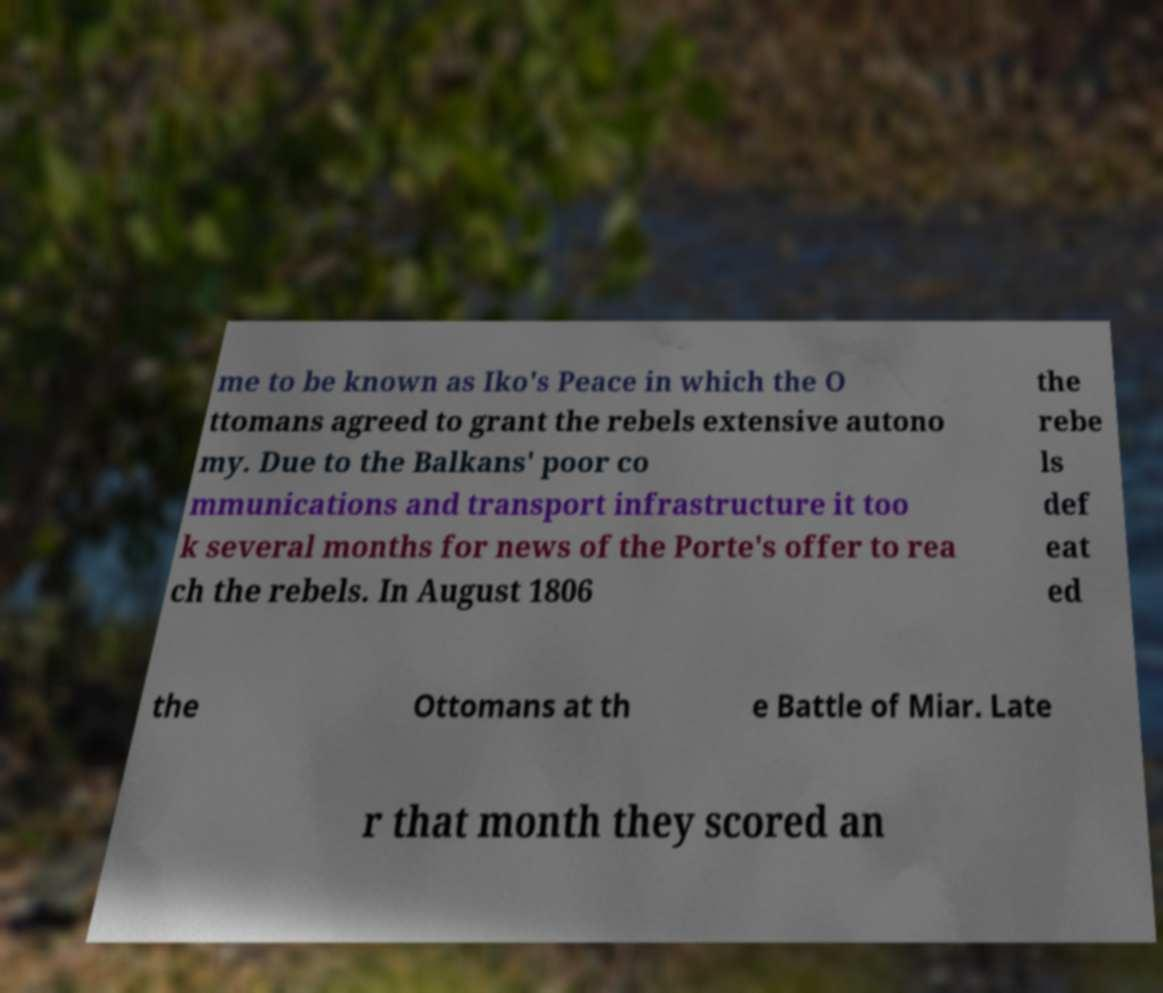Could you extract and type out the text from this image? me to be known as Iko's Peace in which the O ttomans agreed to grant the rebels extensive autono my. Due to the Balkans' poor co mmunications and transport infrastructure it too k several months for news of the Porte's offer to rea ch the rebels. In August 1806 the rebe ls def eat ed the Ottomans at th e Battle of Miar. Late r that month they scored an 